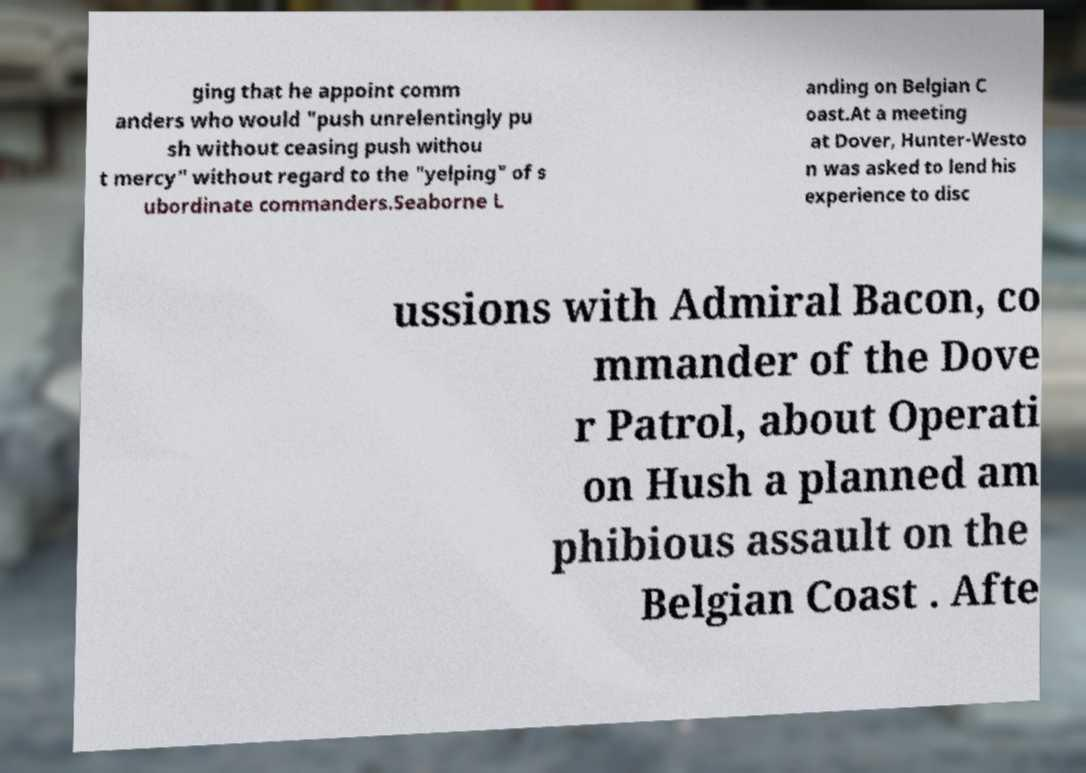Please read and relay the text visible in this image. What does it say? ging that he appoint comm anders who would "push unrelentingly pu sh without ceasing push withou t mercy" without regard to the "yelping" of s ubordinate commanders.Seaborne L anding on Belgian C oast.At a meeting at Dover, Hunter-Westo n was asked to lend his experience to disc ussions with Admiral Bacon, co mmander of the Dove r Patrol, about Operati on Hush a planned am phibious assault on the Belgian Coast . Afte 